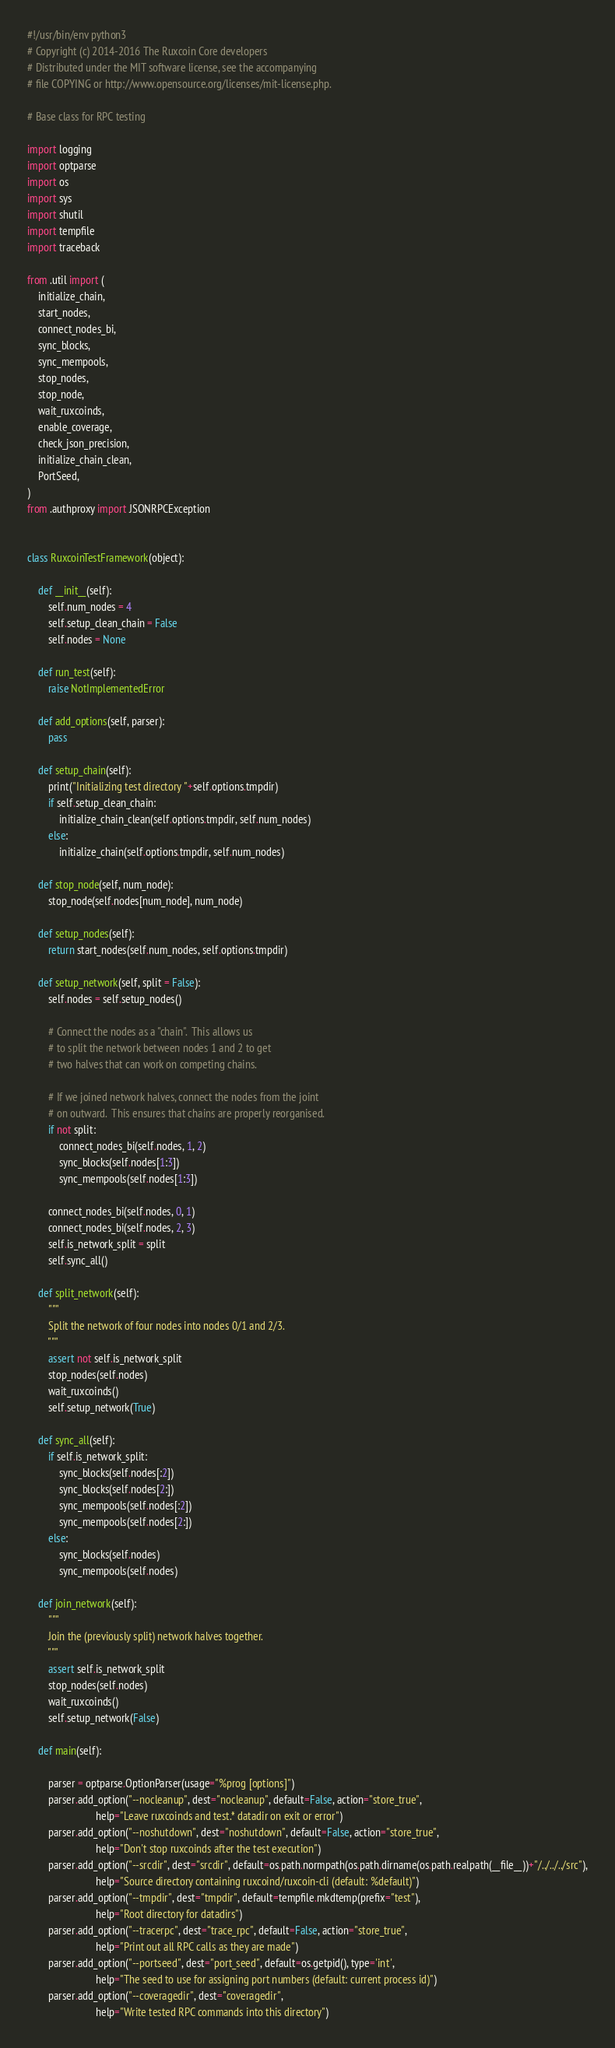Convert code to text. <code><loc_0><loc_0><loc_500><loc_500><_Python_>#!/usr/bin/env python3
# Copyright (c) 2014-2016 The Ruxcoin Core developers
# Distributed under the MIT software license, see the accompanying
# file COPYING or http://www.opensource.org/licenses/mit-license.php.

# Base class for RPC testing

import logging
import optparse
import os
import sys
import shutil
import tempfile
import traceback

from .util import (
    initialize_chain,
    start_nodes,
    connect_nodes_bi,
    sync_blocks,
    sync_mempools,
    stop_nodes,
    stop_node,
    wait_ruxcoinds,
    enable_coverage,
    check_json_precision,
    initialize_chain_clean,
    PortSeed,
)
from .authproxy import JSONRPCException


class RuxcoinTestFramework(object):

    def __init__(self):
        self.num_nodes = 4
        self.setup_clean_chain = False
        self.nodes = None

    def run_test(self):
        raise NotImplementedError

    def add_options(self, parser):
        pass

    def setup_chain(self):
        print("Initializing test directory "+self.options.tmpdir)
        if self.setup_clean_chain:
            initialize_chain_clean(self.options.tmpdir, self.num_nodes)
        else:
            initialize_chain(self.options.tmpdir, self.num_nodes)

    def stop_node(self, num_node):
        stop_node(self.nodes[num_node], num_node)

    def setup_nodes(self):
        return start_nodes(self.num_nodes, self.options.tmpdir)

    def setup_network(self, split = False):
        self.nodes = self.setup_nodes()

        # Connect the nodes as a "chain".  This allows us
        # to split the network between nodes 1 and 2 to get
        # two halves that can work on competing chains.

        # If we joined network halves, connect the nodes from the joint
        # on outward.  This ensures that chains are properly reorganised.
        if not split:
            connect_nodes_bi(self.nodes, 1, 2)
            sync_blocks(self.nodes[1:3])
            sync_mempools(self.nodes[1:3])

        connect_nodes_bi(self.nodes, 0, 1)
        connect_nodes_bi(self.nodes, 2, 3)
        self.is_network_split = split
        self.sync_all()

    def split_network(self):
        """
        Split the network of four nodes into nodes 0/1 and 2/3.
        """
        assert not self.is_network_split
        stop_nodes(self.nodes)
        wait_ruxcoinds()
        self.setup_network(True)

    def sync_all(self):
        if self.is_network_split:
            sync_blocks(self.nodes[:2])
            sync_blocks(self.nodes[2:])
            sync_mempools(self.nodes[:2])
            sync_mempools(self.nodes[2:])
        else:
            sync_blocks(self.nodes)
            sync_mempools(self.nodes)

    def join_network(self):
        """
        Join the (previously split) network halves together.
        """
        assert self.is_network_split
        stop_nodes(self.nodes)
        wait_ruxcoinds()
        self.setup_network(False)

    def main(self):

        parser = optparse.OptionParser(usage="%prog [options]")
        parser.add_option("--nocleanup", dest="nocleanup", default=False, action="store_true",
                          help="Leave ruxcoinds and test.* datadir on exit or error")
        parser.add_option("--noshutdown", dest="noshutdown", default=False, action="store_true",
                          help="Don't stop ruxcoinds after the test execution")
        parser.add_option("--srcdir", dest="srcdir", default=os.path.normpath(os.path.dirname(os.path.realpath(__file__))+"/../../../src"),
                          help="Source directory containing ruxcoind/ruxcoin-cli (default: %default)")
        parser.add_option("--tmpdir", dest="tmpdir", default=tempfile.mkdtemp(prefix="test"),
                          help="Root directory for datadirs")
        parser.add_option("--tracerpc", dest="trace_rpc", default=False, action="store_true",
                          help="Print out all RPC calls as they are made")
        parser.add_option("--portseed", dest="port_seed", default=os.getpid(), type='int',
                          help="The seed to use for assigning port numbers (default: current process id)")
        parser.add_option("--coveragedir", dest="coveragedir",
                          help="Write tested RPC commands into this directory")</code> 